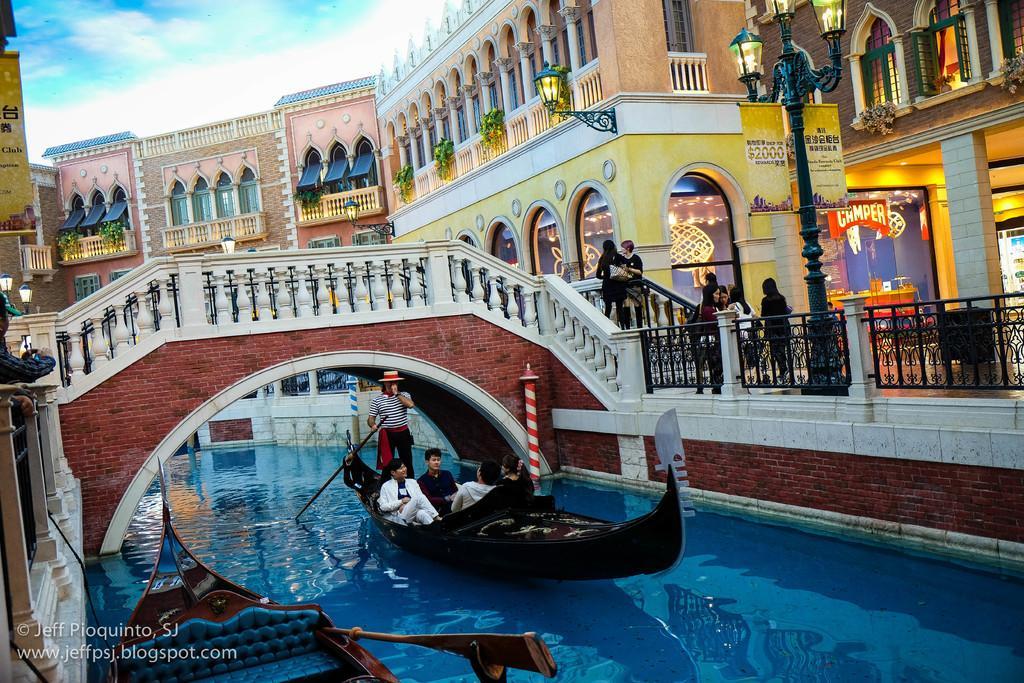In one or two sentences, can you explain what this image depicts? This is a sky. This is a building with few plants. this is a window. this is a balcony. There is a board stating Camper. This is a light. There are few people standing in front of a building. Two women are standing on the stairs and the women with a black dress wearing a handbag. This is a footover bridge. On the right side of the picture we can see a man wearing a cap. This a water. This is a boat. On the boat four people are sitting. One man is standing beside them holding a pedal. This an empty boat. 